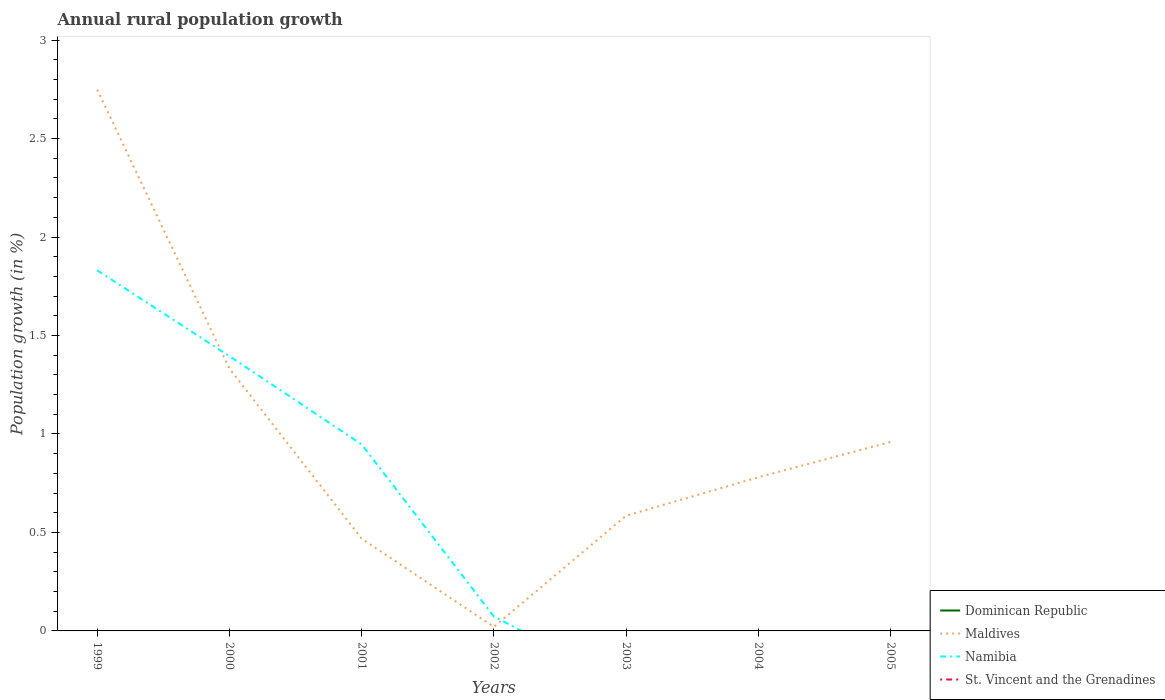How many different coloured lines are there?
Give a very brief answer. 2. Does the line corresponding to Namibia intersect with the line corresponding to Maldives?
Provide a succinct answer. Yes. What is the total percentage of rural population growth in Namibia in the graph?
Give a very brief answer. 1.76. What is the difference between the highest and the second highest percentage of rural population growth in Namibia?
Give a very brief answer. 1.83. What is the difference between the highest and the lowest percentage of rural population growth in Namibia?
Provide a short and direct response. 3. Is the percentage of rural population growth in Dominican Republic strictly greater than the percentage of rural population growth in St. Vincent and the Grenadines over the years?
Your answer should be very brief. No. How many lines are there?
Ensure brevity in your answer.  2. How many years are there in the graph?
Give a very brief answer. 7. Does the graph contain grids?
Give a very brief answer. No. What is the title of the graph?
Your answer should be very brief. Annual rural population growth. Does "Lao PDR" appear as one of the legend labels in the graph?
Provide a short and direct response. No. What is the label or title of the Y-axis?
Provide a succinct answer. Population growth (in %). What is the Population growth (in %) in Dominican Republic in 1999?
Your answer should be very brief. 0. What is the Population growth (in %) in Maldives in 1999?
Your answer should be very brief. 2.75. What is the Population growth (in %) of Namibia in 1999?
Provide a short and direct response. 1.83. What is the Population growth (in %) in St. Vincent and the Grenadines in 1999?
Offer a terse response. 0. What is the Population growth (in %) of Maldives in 2000?
Your answer should be very brief. 1.33. What is the Population growth (in %) of Namibia in 2000?
Provide a succinct answer. 1.4. What is the Population growth (in %) of Maldives in 2001?
Your response must be concise. 0.47. What is the Population growth (in %) in Namibia in 2001?
Provide a short and direct response. 0.95. What is the Population growth (in %) in Dominican Republic in 2002?
Offer a very short reply. 0. What is the Population growth (in %) of Maldives in 2002?
Ensure brevity in your answer.  0.02. What is the Population growth (in %) in Namibia in 2002?
Offer a very short reply. 0.07. What is the Population growth (in %) in St. Vincent and the Grenadines in 2002?
Ensure brevity in your answer.  0. What is the Population growth (in %) in Maldives in 2003?
Your answer should be compact. 0.58. What is the Population growth (in %) in St. Vincent and the Grenadines in 2003?
Ensure brevity in your answer.  0. What is the Population growth (in %) of Dominican Republic in 2004?
Your response must be concise. 0. What is the Population growth (in %) of Maldives in 2004?
Offer a terse response. 0.78. What is the Population growth (in %) in Namibia in 2004?
Your response must be concise. 0. What is the Population growth (in %) of Maldives in 2005?
Provide a succinct answer. 0.96. What is the Population growth (in %) in St. Vincent and the Grenadines in 2005?
Your answer should be very brief. 0. Across all years, what is the maximum Population growth (in %) of Maldives?
Make the answer very short. 2.75. Across all years, what is the maximum Population growth (in %) of Namibia?
Give a very brief answer. 1.83. Across all years, what is the minimum Population growth (in %) in Maldives?
Make the answer very short. 0.02. Across all years, what is the minimum Population growth (in %) in Namibia?
Your answer should be compact. 0. What is the total Population growth (in %) of Maldives in the graph?
Keep it short and to the point. 6.89. What is the total Population growth (in %) of Namibia in the graph?
Ensure brevity in your answer.  4.25. What is the total Population growth (in %) of St. Vincent and the Grenadines in the graph?
Offer a very short reply. 0. What is the difference between the Population growth (in %) in Maldives in 1999 and that in 2000?
Make the answer very short. 1.42. What is the difference between the Population growth (in %) of Namibia in 1999 and that in 2000?
Make the answer very short. 0.44. What is the difference between the Population growth (in %) of Maldives in 1999 and that in 2001?
Provide a succinct answer. 2.28. What is the difference between the Population growth (in %) of Namibia in 1999 and that in 2001?
Your answer should be compact. 0.88. What is the difference between the Population growth (in %) in Maldives in 1999 and that in 2002?
Your answer should be compact. 2.73. What is the difference between the Population growth (in %) in Namibia in 1999 and that in 2002?
Your response must be concise. 1.76. What is the difference between the Population growth (in %) of Maldives in 1999 and that in 2003?
Offer a very short reply. 2.16. What is the difference between the Population growth (in %) of Maldives in 1999 and that in 2004?
Offer a terse response. 1.97. What is the difference between the Population growth (in %) in Maldives in 1999 and that in 2005?
Your answer should be compact. 1.79. What is the difference between the Population growth (in %) in Maldives in 2000 and that in 2001?
Offer a terse response. 0.86. What is the difference between the Population growth (in %) of Namibia in 2000 and that in 2001?
Offer a very short reply. 0.45. What is the difference between the Population growth (in %) of Maldives in 2000 and that in 2002?
Your response must be concise. 1.31. What is the difference between the Population growth (in %) in Namibia in 2000 and that in 2002?
Provide a succinct answer. 1.32. What is the difference between the Population growth (in %) of Maldives in 2000 and that in 2003?
Make the answer very short. 0.75. What is the difference between the Population growth (in %) in Maldives in 2000 and that in 2004?
Provide a succinct answer. 0.55. What is the difference between the Population growth (in %) in Maldives in 2000 and that in 2005?
Offer a terse response. 0.37. What is the difference between the Population growth (in %) in Maldives in 2001 and that in 2002?
Your answer should be compact. 0.45. What is the difference between the Population growth (in %) of Namibia in 2001 and that in 2002?
Your answer should be compact. 0.87. What is the difference between the Population growth (in %) in Maldives in 2001 and that in 2003?
Give a very brief answer. -0.12. What is the difference between the Population growth (in %) of Maldives in 2001 and that in 2004?
Your answer should be very brief. -0.31. What is the difference between the Population growth (in %) in Maldives in 2001 and that in 2005?
Your response must be concise. -0.49. What is the difference between the Population growth (in %) in Maldives in 2002 and that in 2003?
Give a very brief answer. -0.56. What is the difference between the Population growth (in %) in Maldives in 2002 and that in 2004?
Keep it short and to the point. -0.76. What is the difference between the Population growth (in %) in Maldives in 2002 and that in 2005?
Your answer should be very brief. -0.94. What is the difference between the Population growth (in %) of Maldives in 2003 and that in 2004?
Ensure brevity in your answer.  -0.2. What is the difference between the Population growth (in %) of Maldives in 2003 and that in 2005?
Make the answer very short. -0.37. What is the difference between the Population growth (in %) of Maldives in 2004 and that in 2005?
Offer a very short reply. -0.18. What is the difference between the Population growth (in %) of Maldives in 1999 and the Population growth (in %) of Namibia in 2000?
Your response must be concise. 1.35. What is the difference between the Population growth (in %) in Maldives in 1999 and the Population growth (in %) in Namibia in 2001?
Keep it short and to the point. 1.8. What is the difference between the Population growth (in %) in Maldives in 1999 and the Population growth (in %) in Namibia in 2002?
Offer a terse response. 2.67. What is the difference between the Population growth (in %) in Maldives in 2000 and the Population growth (in %) in Namibia in 2001?
Keep it short and to the point. 0.39. What is the difference between the Population growth (in %) in Maldives in 2000 and the Population growth (in %) in Namibia in 2002?
Ensure brevity in your answer.  1.26. What is the difference between the Population growth (in %) in Maldives in 2001 and the Population growth (in %) in Namibia in 2002?
Your answer should be very brief. 0.4. What is the average Population growth (in %) of Maldives per year?
Provide a short and direct response. 0.98. What is the average Population growth (in %) of Namibia per year?
Give a very brief answer. 0.61. What is the average Population growth (in %) of St. Vincent and the Grenadines per year?
Keep it short and to the point. 0. In the year 1999, what is the difference between the Population growth (in %) in Maldives and Population growth (in %) in Namibia?
Your response must be concise. 0.92. In the year 2000, what is the difference between the Population growth (in %) of Maldives and Population growth (in %) of Namibia?
Your response must be concise. -0.06. In the year 2001, what is the difference between the Population growth (in %) of Maldives and Population growth (in %) of Namibia?
Your response must be concise. -0.48. In the year 2002, what is the difference between the Population growth (in %) in Maldives and Population growth (in %) in Namibia?
Your response must be concise. -0.05. What is the ratio of the Population growth (in %) in Maldives in 1999 to that in 2000?
Give a very brief answer. 2.06. What is the ratio of the Population growth (in %) of Namibia in 1999 to that in 2000?
Give a very brief answer. 1.31. What is the ratio of the Population growth (in %) in Maldives in 1999 to that in 2001?
Provide a short and direct response. 5.87. What is the ratio of the Population growth (in %) in Namibia in 1999 to that in 2001?
Provide a short and direct response. 1.93. What is the ratio of the Population growth (in %) in Maldives in 1999 to that in 2002?
Your response must be concise. 132.79. What is the ratio of the Population growth (in %) of Namibia in 1999 to that in 2002?
Offer a terse response. 24.93. What is the ratio of the Population growth (in %) of Maldives in 1999 to that in 2003?
Your answer should be compact. 4.7. What is the ratio of the Population growth (in %) of Maldives in 1999 to that in 2004?
Your response must be concise. 3.52. What is the ratio of the Population growth (in %) of Maldives in 1999 to that in 2005?
Ensure brevity in your answer.  2.86. What is the ratio of the Population growth (in %) in Maldives in 2000 to that in 2001?
Ensure brevity in your answer.  2.84. What is the ratio of the Population growth (in %) in Namibia in 2000 to that in 2001?
Provide a succinct answer. 1.47. What is the ratio of the Population growth (in %) of Maldives in 2000 to that in 2002?
Your response must be concise. 64.36. What is the ratio of the Population growth (in %) of Namibia in 2000 to that in 2002?
Your answer should be very brief. 19. What is the ratio of the Population growth (in %) of Maldives in 2000 to that in 2003?
Offer a terse response. 2.28. What is the ratio of the Population growth (in %) in Maldives in 2000 to that in 2004?
Provide a succinct answer. 1.71. What is the ratio of the Population growth (in %) of Maldives in 2000 to that in 2005?
Give a very brief answer. 1.39. What is the ratio of the Population growth (in %) in Maldives in 2001 to that in 2002?
Provide a succinct answer. 22.64. What is the ratio of the Population growth (in %) in Namibia in 2001 to that in 2002?
Provide a succinct answer. 12.9. What is the ratio of the Population growth (in %) of Maldives in 2001 to that in 2003?
Offer a terse response. 0.8. What is the ratio of the Population growth (in %) of Maldives in 2001 to that in 2004?
Provide a succinct answer. 0.6. What is the ratio of the Population growth (in %) of Maldives in 2001 to that in 2005?
Provide a short and direct response. 0.49. What is the ratio of the Population growth (in %) in Maldives in 2002 to that in 2003?
Ensure brevity in your answer.  0.04. What is the ratio of the Population growth (in %) of Maldives in 2002 to that in 2004?
Offer a terse response. 0.03. What is the ratio of the Population growth (in %) in Maldives in 2002 to that in 2005?
Your answer should be very brief. 0.02. What is the ratio of the Population growth (in %) of Maldives in 2003 to that in 2004?
Offer a terse response. 0.75. What is the ratio of the Population growth (in %) in Maldives in 2003 to that in 2005?
Ensure brevity in your answer.  0.61. What is the ratio of the Population growth (in %) of Maldives in 2004 to that in 2005?
Provide a succinct answer. 0.81. What is the difference between the highest and the second highest Population growth (in %) of Maldives?
Provide a succinct answer. 1.42. What is the difference between the highest and the second highest Population growth (in %) of Namibia?
Ensure brevity in your answer.  0.44. What is the difference between the highest and the lowest Population growth (in %) of Maldives?
Provide a succinct answer. 2.73. What is the difference between the highest and the lowest Population growth (in %) in Namibia?
Your answer should be compact. 1.83. 